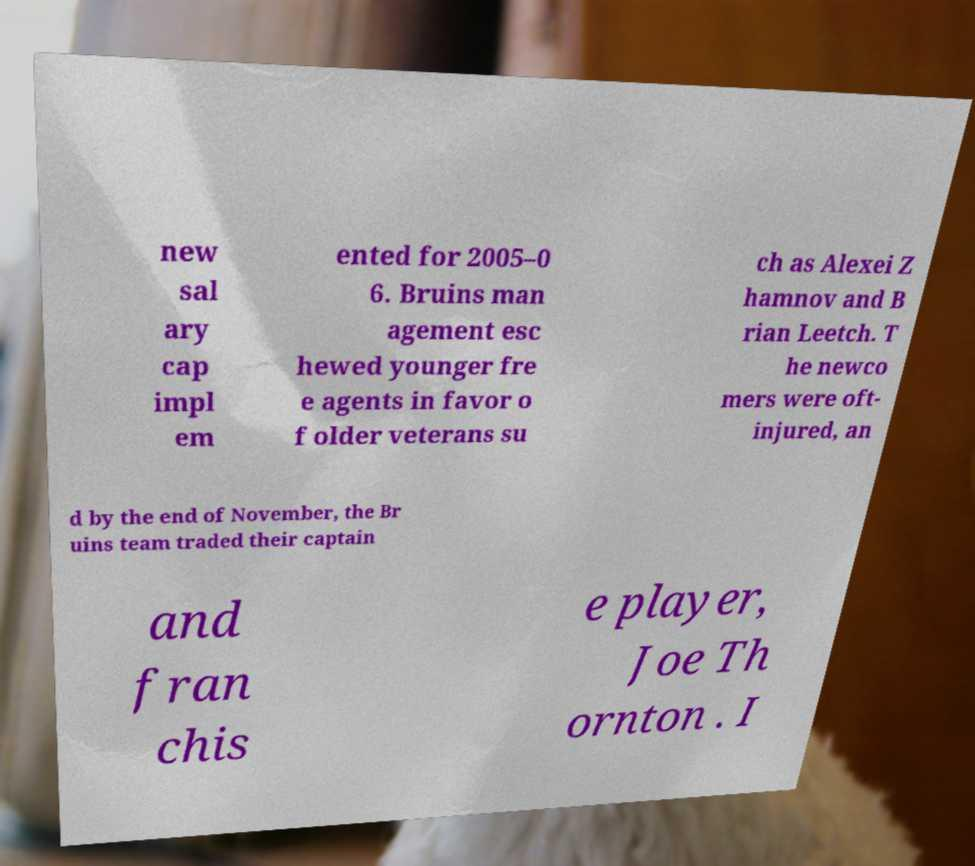Can you accurately transcribe the text from the provided image for me? new sal ary cap impl em ented for 2005–0 6. Bruins man agement esc hewed younger fre e agents in favor o f older veterans su ch as Alexei Z hamnov and B rian Leetch. T he newco mers were oft- injured, an d by the end of November, the Br uins team traded their captain and fran chis e player, Joe Th ornton . I 